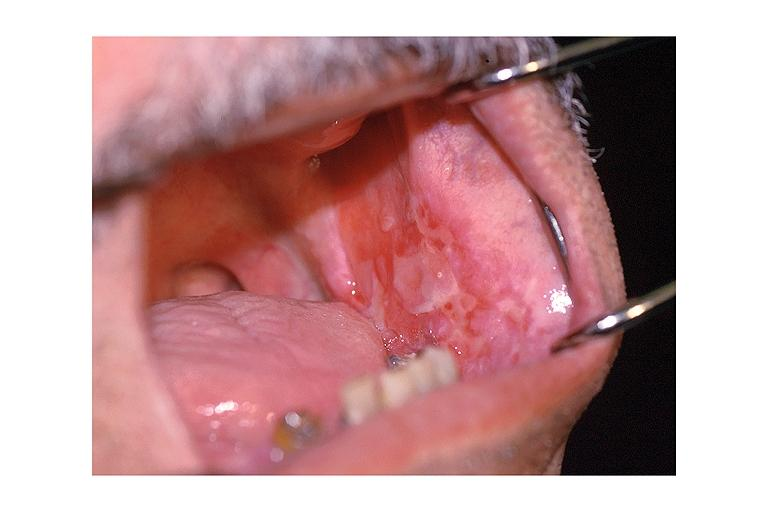where is this?
Answer the question using a single word or phrase. Oral 